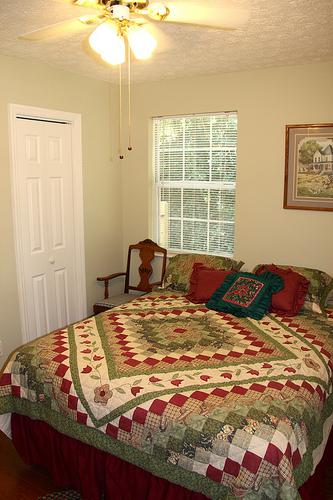Question: where was the photo taken?
Choices:
A. Bathroom.
B. In a bedroom.
C. Closet.
D. Garage.
Answer with the letter. Answer: B Question: what is white?
Choices:
A. Floor.
B. Ceiling.
C. Furniture.
D. Walls.
Answer with the letter. Answer: D Question: where is a ceiling?
Choices:
A. Above.
B. Two stories up.
C. Hanging low overhead.
D. On the ceiling.
Answer with the letter. Answer: D Question: what is open?
Choices:
A. Window.
B. Front door.
C. Car door.
D. Blinds.
Answer with the letter. Answer: D Question: how many pillows are on a bed?
Choices:
A. Five.
B. Four.
C. Three.
D. Two.
Answer with the letter. Answer: A 